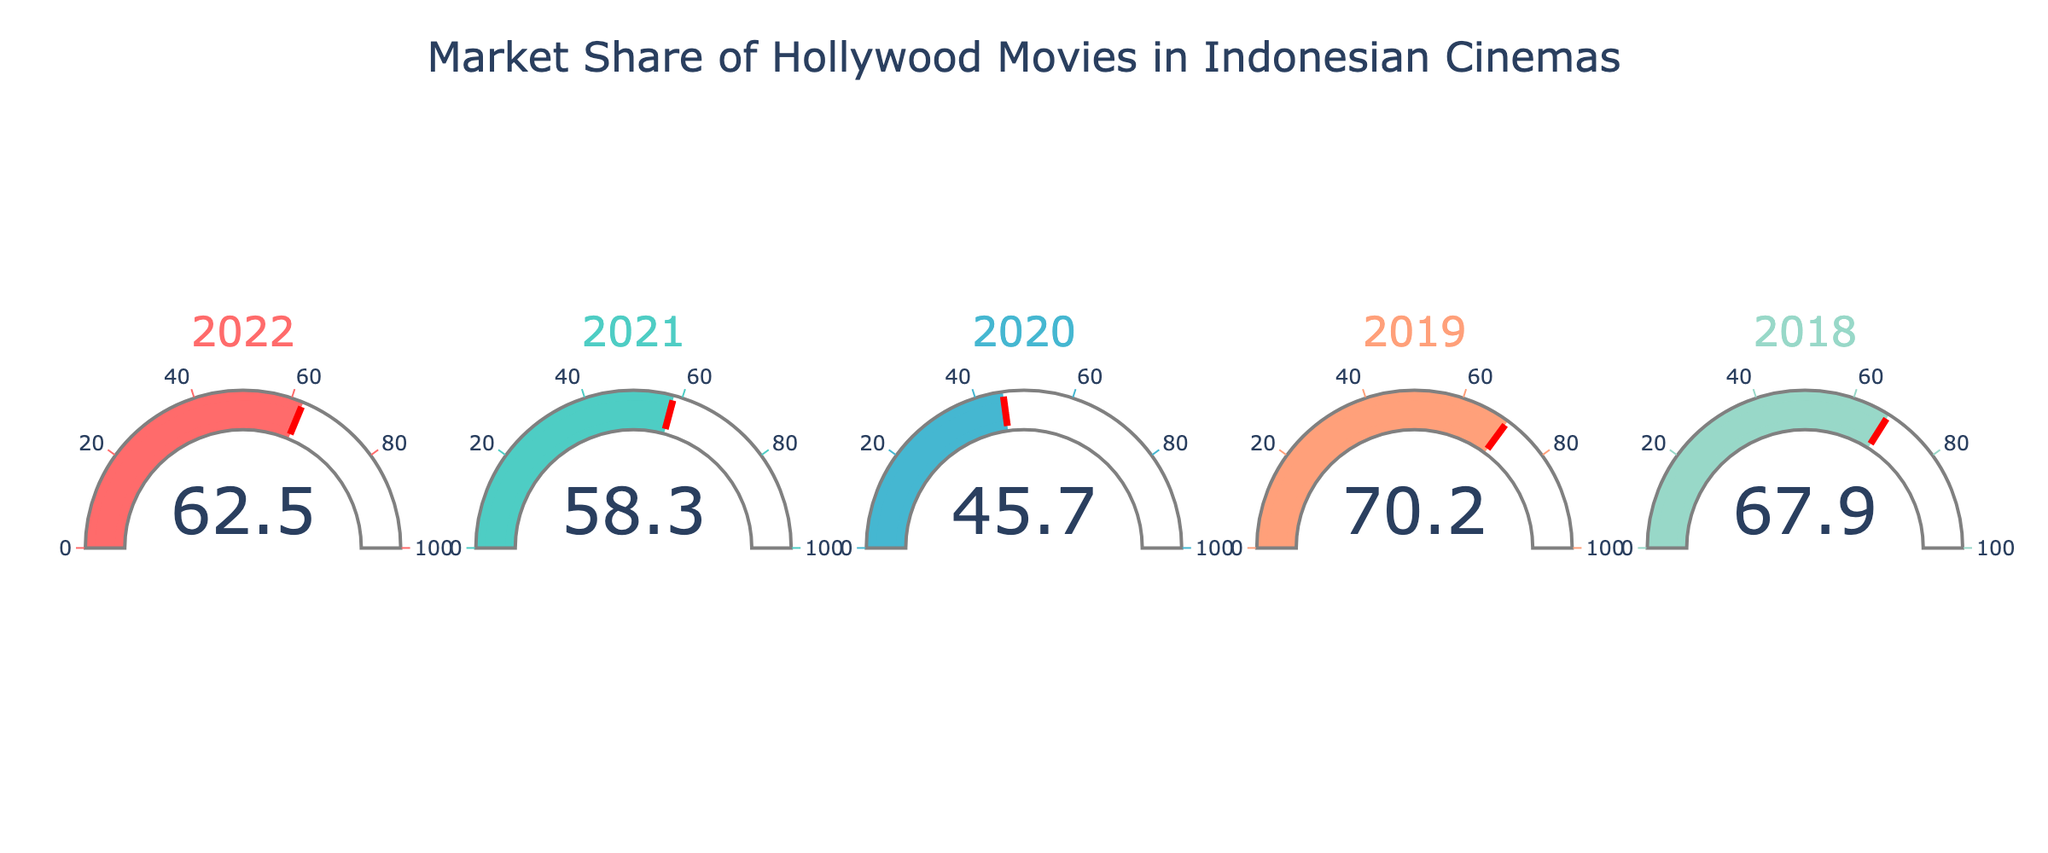What is the title of the gauge chart? The title is located at the top of the chart. It reads "Market Share of Hollywood Movies in Indonesian Cinemas".
Answer: Market Share of Hollywood Movies in Indonesian Cinemas How many years are shown in the gauge chart? Each gauge represents a different year. By counting the gauges, we can see there are five years displayed.
Answer: Five What was the market share of Hollywood movies in Indonesian cinemas in 2019? The gauge labeled "2019" shows the market share value, which is 70.2%.
Answer: 70.2% Which year had the lowest market share of Hollywood movies in Indonesian cinemas? By comparing the values on all five gauges, the year with the lowest market share is 2020 with 45.7%.
Answer: 2020 What is the average market share of Hollywood movies in Indonesian cinemas from 2018 to 2022? Sum the market share values of each year (67.9 + 70.2 + 45.7 + 58.3 + 62.5) and then divide by the number of years (5). The average is (67.9 + 70.2 + 45.7 + 58.3 + 62.5) / 5 = 60.92.
Answer: 60.92% In which year did Hollywood movies have a market share higher than 60%? The gauges for the years 2018 (67.9%), 2019 (70.2%), 2021 (58.3%), and 2022 (62.5%) show values. Among them, only 2018, 2019, and 2022 had values higher than 60%.
Answer: 2018, 2019, 2022 What is the range of market shares over the five years depicted? Identify the highest and lowest market share values. The highest is 70.2% (2019) and the lowest is 45.7% (2020). The range is 70.2 - 45.7 = 24.5%.
Answer: 24.5% How does the market share in 2020 compare to the previous year? Compare the gauge values of 2020 and 2019. 2020 has 45.7% and 2019 has 70.2%. A difference of 70.2 - 45.7 = 24.5%.  The market share decreased by 24.5%.
Answer: Decreased by 24.5% Which year had the second highest market share of Hollywood movies? Rank the market shares from highest to lowest: 70.2% (2019), 67.9% (2018), 62.5% (2022), 58.3% (2021), 45.7% (2020). The second highest is 67.9% in 2018.
Answer: 2018 